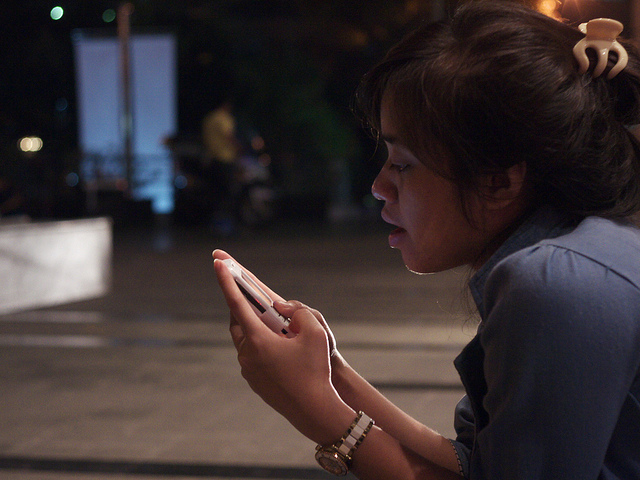<image>What is the person sitting on? I am not sure what the person is sitting on. It could be a bench, a chair, the floor, or against a wall. How many girl are on the bench? I am not sure how many girls are on the bench. But it can be seen one girl. What is outside the window? It is not possible to determine what is outside the window. What sport is the girl playing? The girl is not playing any sport. Is this a warm and sunny climate? I don't know if it's a warm and sunny climate. It's ambiguous and could be both yes or no. What is the person sitting on? I am not sure what the person is sitting on. It can be a bench, a floor or a chair. What sport is the girl playing? It is unknown what sport the girl is playing. What is outside the window? It is ambiguous what is outside the window. It can be people, sky or something blue. How many girl are on the bench? It is uncertain how many girls are on the bench. But it can be seen that there is at least one girl. Is this a warm and sunny climate? I don't know if this is a warm and sunny climate. It can be both warm and sunny or not. 